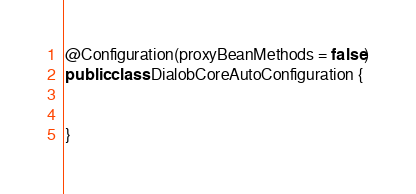<code> <loc_0><loc_0><loc_500><loc_500><_Java_>
@Configuration(proxyBeanMethods = false)
public class DialobCoreAutoConfiguration {


}
</code> 